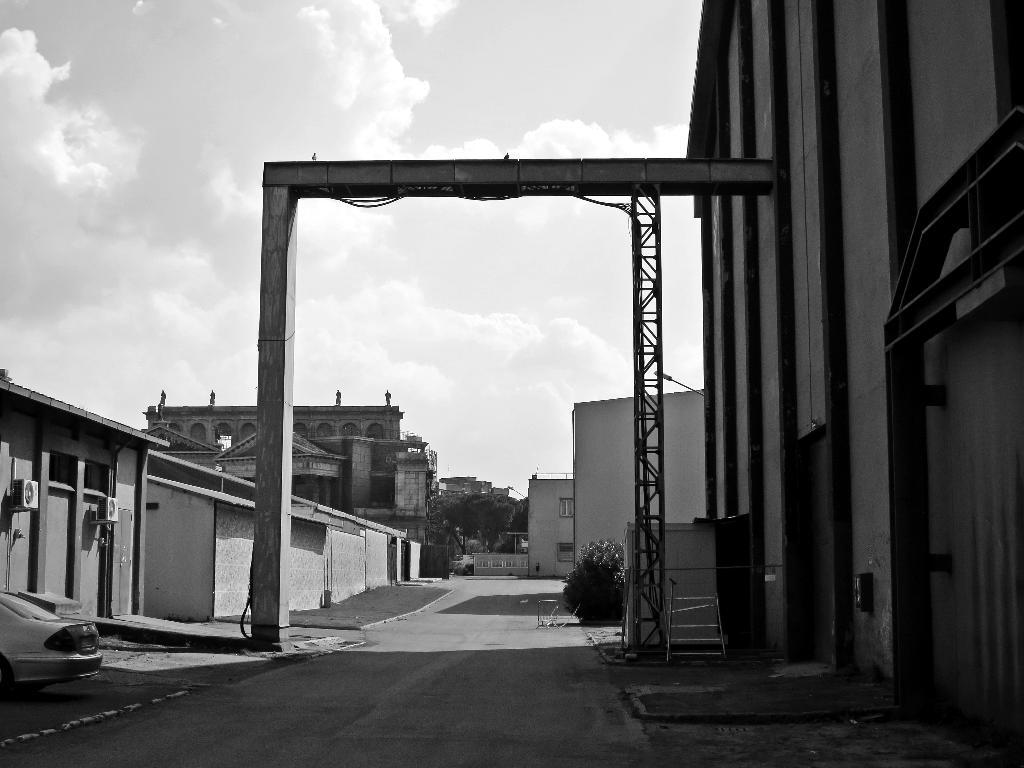What is the main feature of the image? There is a road in the image. How is the road positioned in relation to other structures? The road is situated between buildings. What can be seen in the middle of the image? There is an arch in the middle of the image. What is visible in the background of the image? The sky is visible in the background of the image. What type of instrument is being played by the nut in the image? There is no instrument or nut present in the image. 